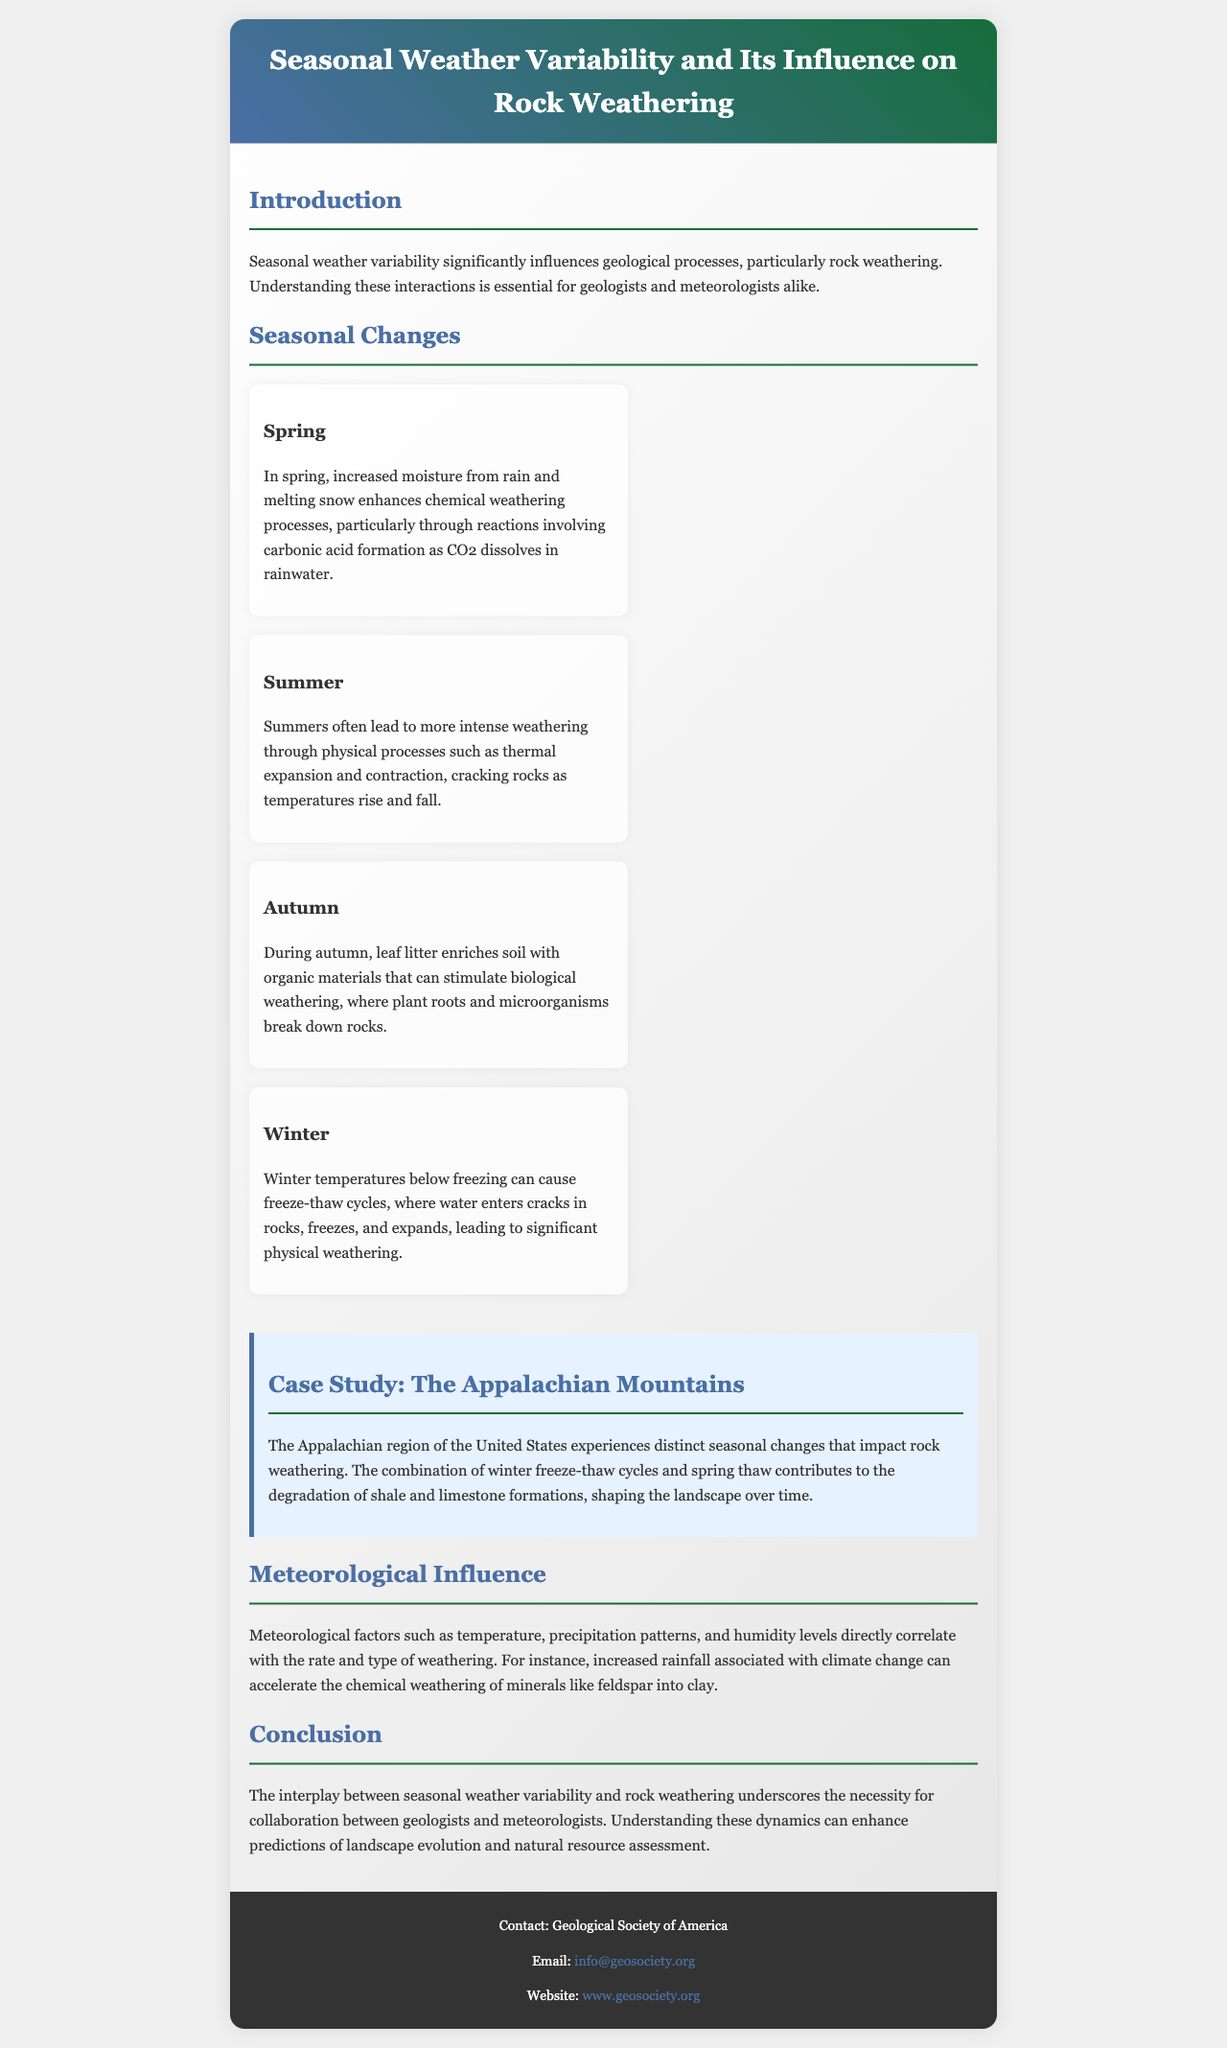What is the title of the brochure? The title is explicitly stated in the header section of the document.
Answer: Seasonal Weather Variability and Its Influence on Rock Weathering What season enhances chemical weathering through carbonic acid formation? Spring is identified in the content as the season that increases moisture and enhances chemical weathering.
Answer: Spring Which season causes physical weathering through thermal expansion and contraction? Summer is described in the document as the season leading to intense weathering due to temperature variations.
Answer: Summer What geological formations are mentioned in the case study? The case study specifically mentions shale and limestone formations in the Appalachian region.
Answer: Shale and limestone What meteorological factor is linked to the acceleration of chemical weathering? Increased rainfall is highlighted as a meteorological factor that correlates with accelerated weathering processes.
Answer: Increased rainfall How many seasons are discussed in the brochure? The document discusses four distinct seasons related to weathering processes.
Answer: Four What is a significant outcome of the interaction between seasonal weather variability and rock weathering? The conclusion highlights the importance of understanding these dynamics for predicting landscape evolution.
Answer: Predicting landscape evolution Who can be contacted for more information about the brochure? The footer section provides contact details for the Geological Society of America.
Answer: Geological Society of America 